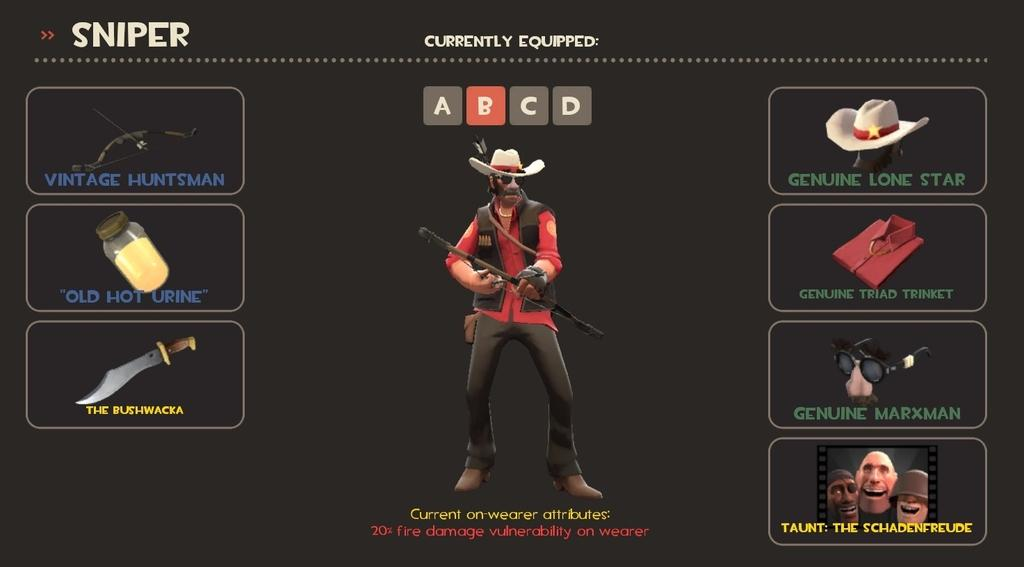What type of objects or characters are animated in the image? There are animated things in the image, but the specifics are not mentioned. Can you describe the person in the image? There is a person in the image, but their appearance or actions are not specified. What kind of text is written on the image? The text written on the image is not described in detail. How many vans are parked in front of the person's home in the image? There is no mention of a home or vans in the image, so this question cannot be answered. 